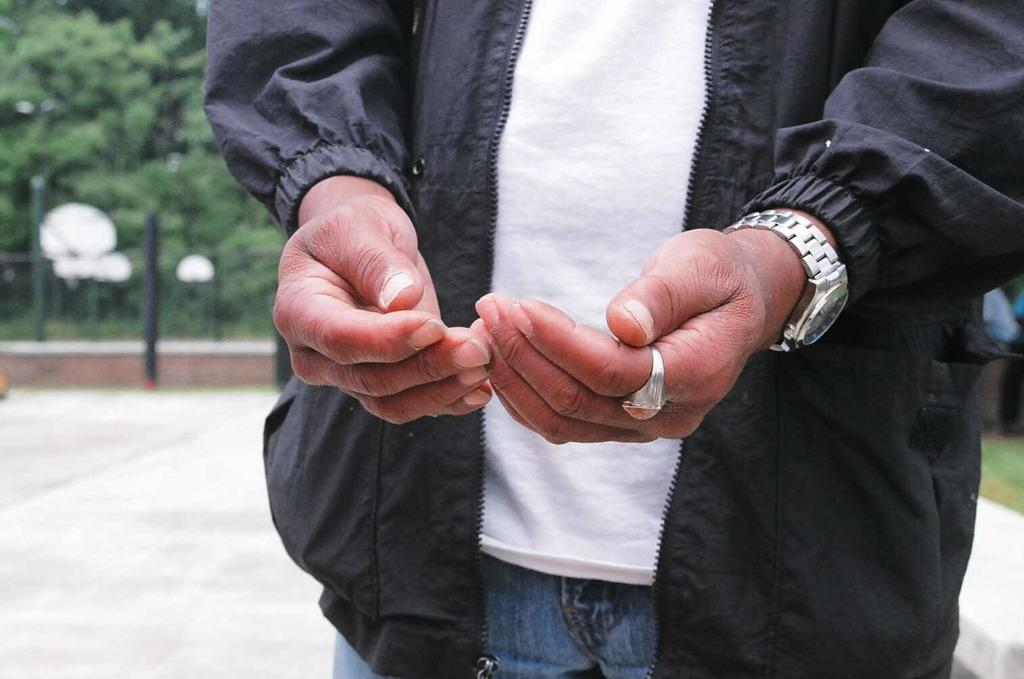What is partially visible in the image? There is a partial picture of a person in the image. What can be seen beneath the person in the image? The ground is visible in the image. How would you describe the background of the image? The background of the image is blurred. What objects can be seen in the background of the image? There is a pole, fencing, and trees in the background of the image. Where is the kettle located in the image? There is no kettle present in the image. What type of quartz can be seen in the image? There is no quartz present in the image. 